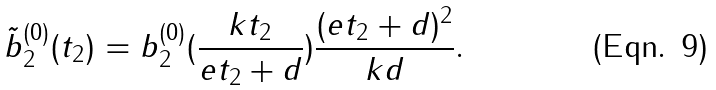Convert formula to latex. <formula><loc_0><loc_0><loc_500><loc_500>\tilde { b } _ { 2 } ^ { ( 0 ) } ( t _ { 2 } ) = b _ { 2 } ^ { ( 0 ) } ( \frac { k t _ { 2 } } { e t _ { 2 } + d } ) \frac { ( e t _ { 2 } + d ) ^ { 2 } } { k d } .</formula> 